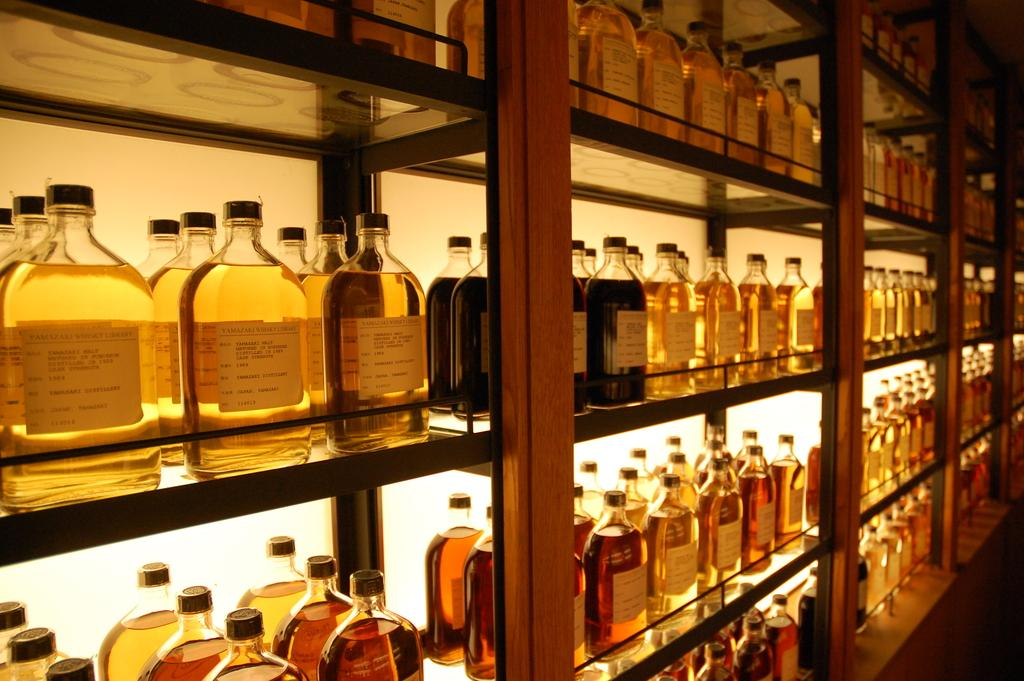What type of structure is present in the image? There are shelves in the image. What materials are used to construct the shelves? The shelves are made of glass and wood. What can be found on the shelves? There are multiple bottles on the shelves. What do the bottles contain? The bottles contain drinks. Is there a jail visible in the image? No, there is no jail present in the image. Can you describe how the bottles are slipping off the shelves in the image? The bottles are not slipping off the shelves in the image; they are securely placed on the glass and wood shelves. 